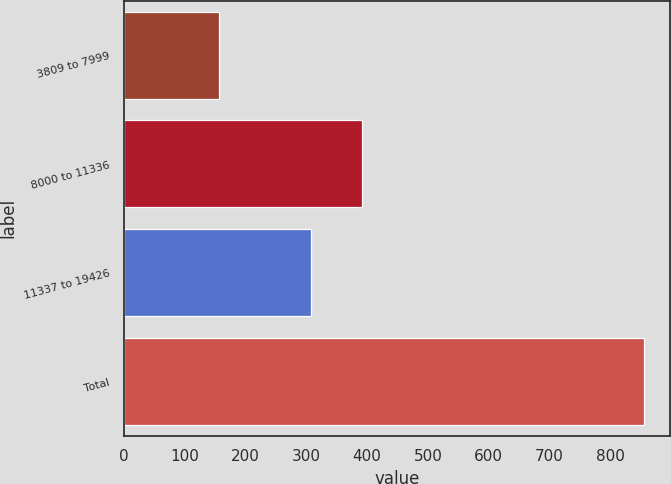<chart> <loc_0><loc_0><loc_500><loc_500><bar_chart><fcel>3809 to 7999<fcel>8000 to 11336<fcel>11337 to 19426<fcel>Total<nl><fcel>157<fcel>391<fcel>307<fcel>855<nl></chart> 